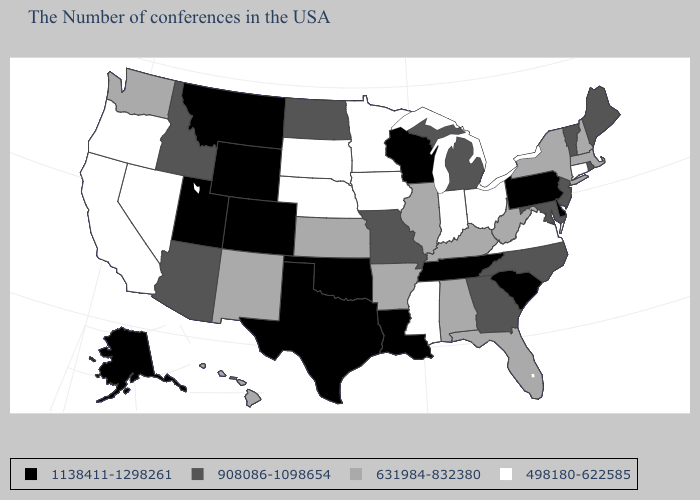Among the states that border Pennsylvania , which have the lowest value?
Be succinct. Ohio. Name the states that have a value in the range 908086-1098654?
Quick response, please. Maine, Rhode Island, Vermont, New Jersey, Maryland, North Carolina, Georgia, Michigan, Missouri, North Dakota, Arizona, Idaho. Which states hav the highest value in the MidWest?
Give a very brief answer. Wisconsin. What is the value of Kansas?
Short answer required. 631984-832380. Does Kentucky have the same value as Arizona?
Be succinct. No. How many symbols are there in the legend?
Quick response, please. 4. Which states have the lowest value in the USA?
Keep it brief. Connecticut, Virginia, Ohio, Indiana, Mississippi, Minnesota, Iowa, Nebraska, South Dakota, Nevada, California, Oregon. Does the map have missing data?
Be succinct. No. Does Idaho have the same value as Nevada?
Write a very short answer. No. Does Illinois have a lower value than New Hampshire?
Keep it brief. No. Does the first symbol in the legend represent the smallest category?
Concise answer only. No. What is the value of Louisiana?
Keep it brief. 1138411-1298261. Name the states that have a value in the range 1138411-1298261?
Be succinct. Delaware, Pennsylvania, South Carolina, Tennessee, Wisconsin, Louisiana, Oklahoma, Texas, Wyoming, Colorado, Utah, Montana, Alaska. What is the value of Colorado?
Answer briefly. 1138411-1298261. Which states have the lowest value in the USA?
Keep it brief. Connecticut, Virginia, Ohio, Indiana, Mississippi, Minnesota, Iowa, Nebraska, South Dakota, Nevada, California, Oregon. 